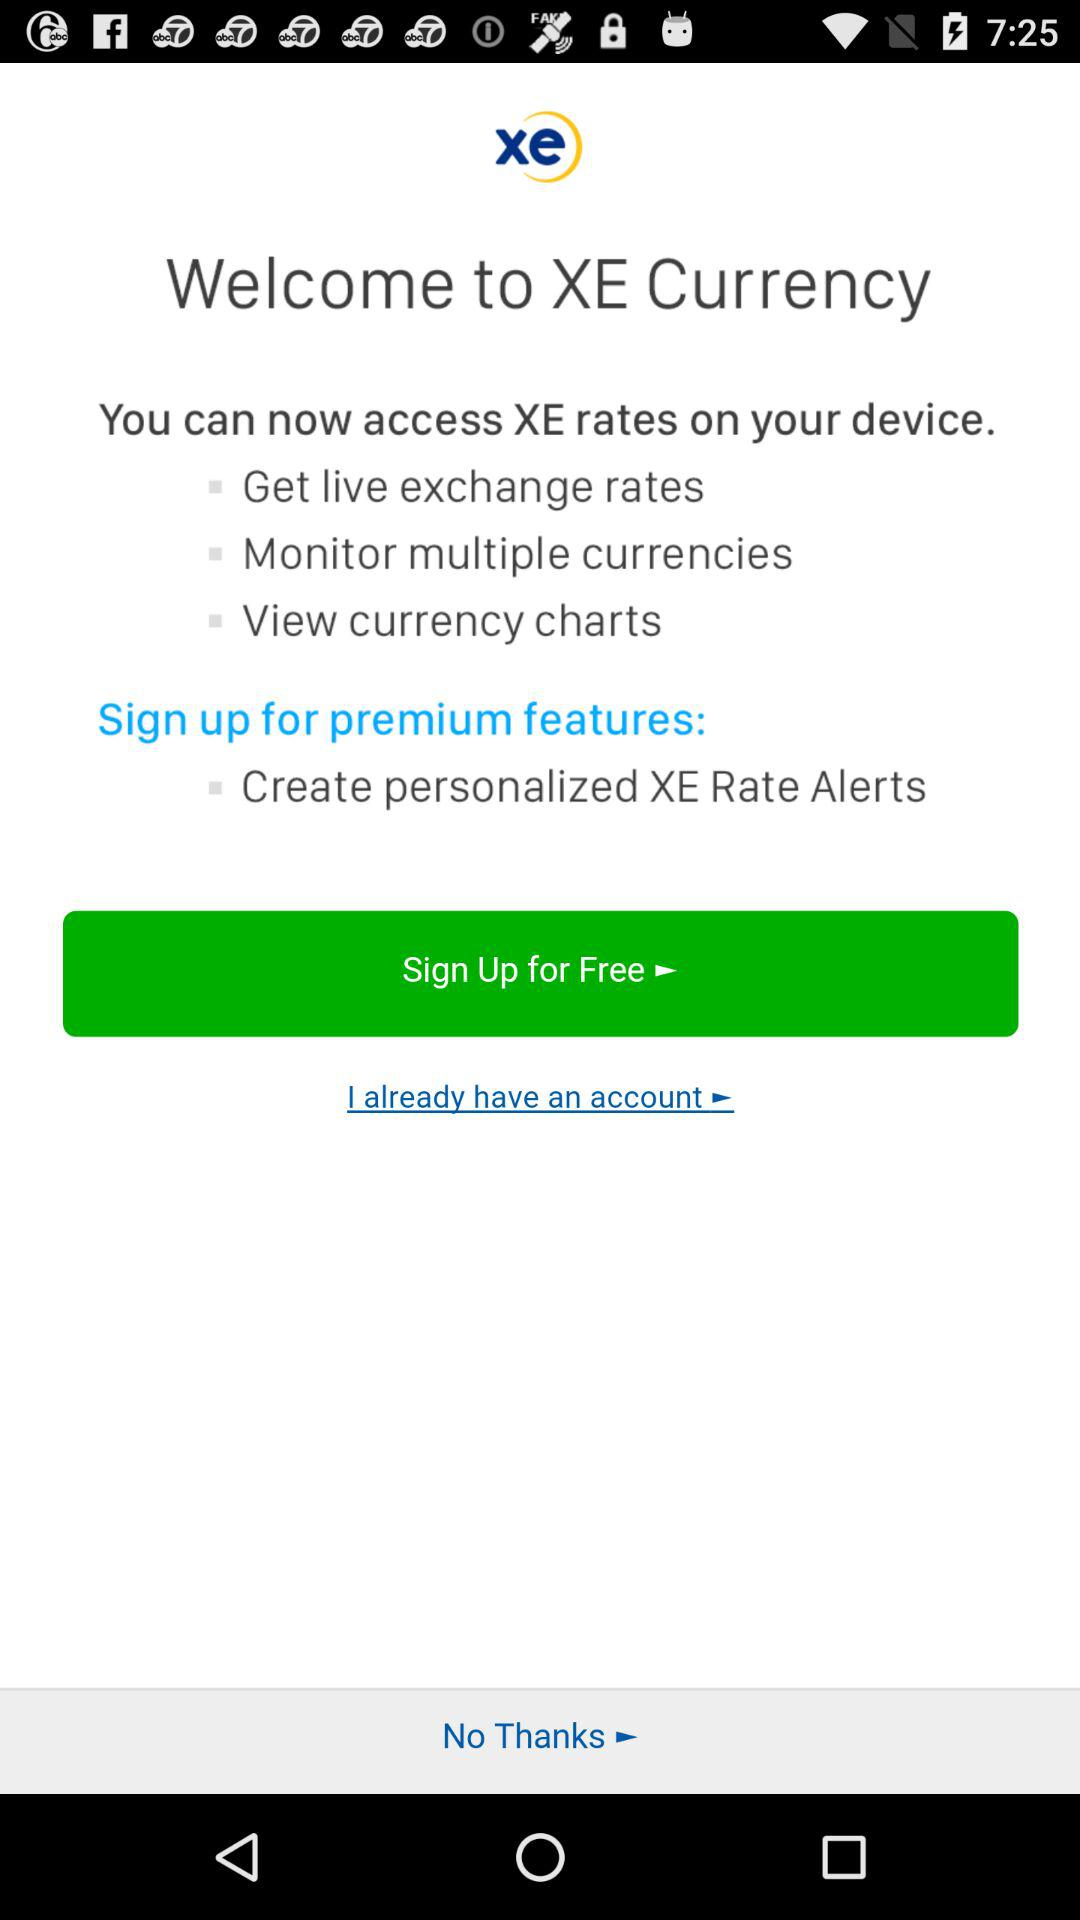What premium features are available by signing up? The premium feature is "Create personalized XE Rate Alerts". 